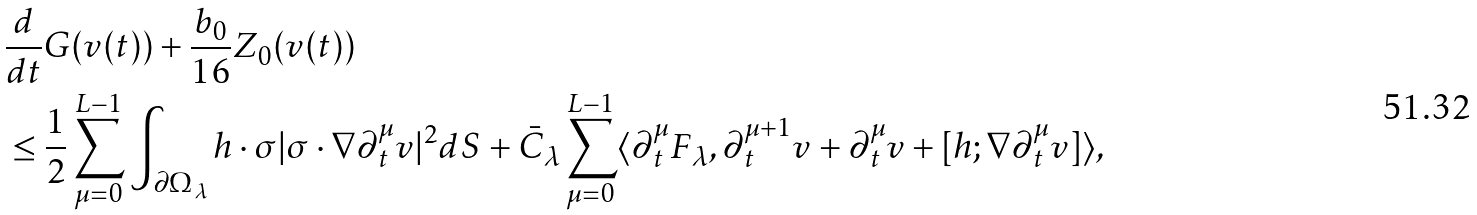<formula> <loc_0><loc_0><loc_500><loc_500>& \frac { d } { d t } G ( v ( t ) ) + \frac { b _ { 0 } } { 1 6 } Z _ { 0 } ( v ( t ) ) \\ & \leq \frac { 1 } { 2 } \sum _ { \mu = 0 } ^ { L - 1 } \int _ { \partial \Omega _ { \lambda } } h \cdot \sigma | \sigma \cdot \nabla \partial _ { t } ^ { \mu } v | ^ { 2 } d S + \bar { C } _ { \lambda } \sum _ { \mu = 0 } ^ { L - 1 } \langle \partial _ { t } ^ { \mu } F _ { \lambda } , \partial _ { t } ^ { \mu + 1 } v + \partial _ { t } ^ { \mu } v + [ h ; \nabla \partial _ { t } ^ { \mu } v ] \rangle ,</formula> 